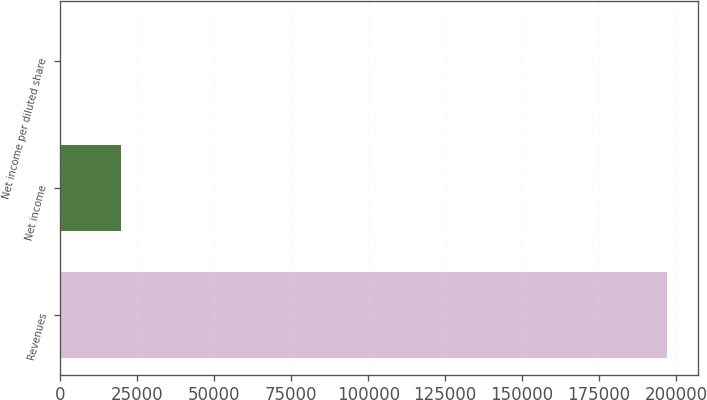Convert chart to OTSL. <chart><loc_0><loc_0><loc_500><loc_500><bar_chart><fcel>Revenues<fcel>Net income<fcel>Net income per diluted share<nl><fcel>197174<fcel>19717.5<fcel>0.14<nl></chart> 